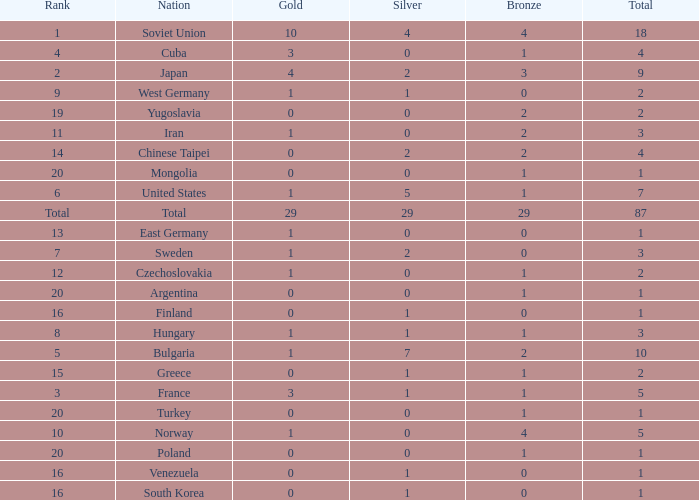What is the average number of bronze medals for total of all nations? 29.0. 